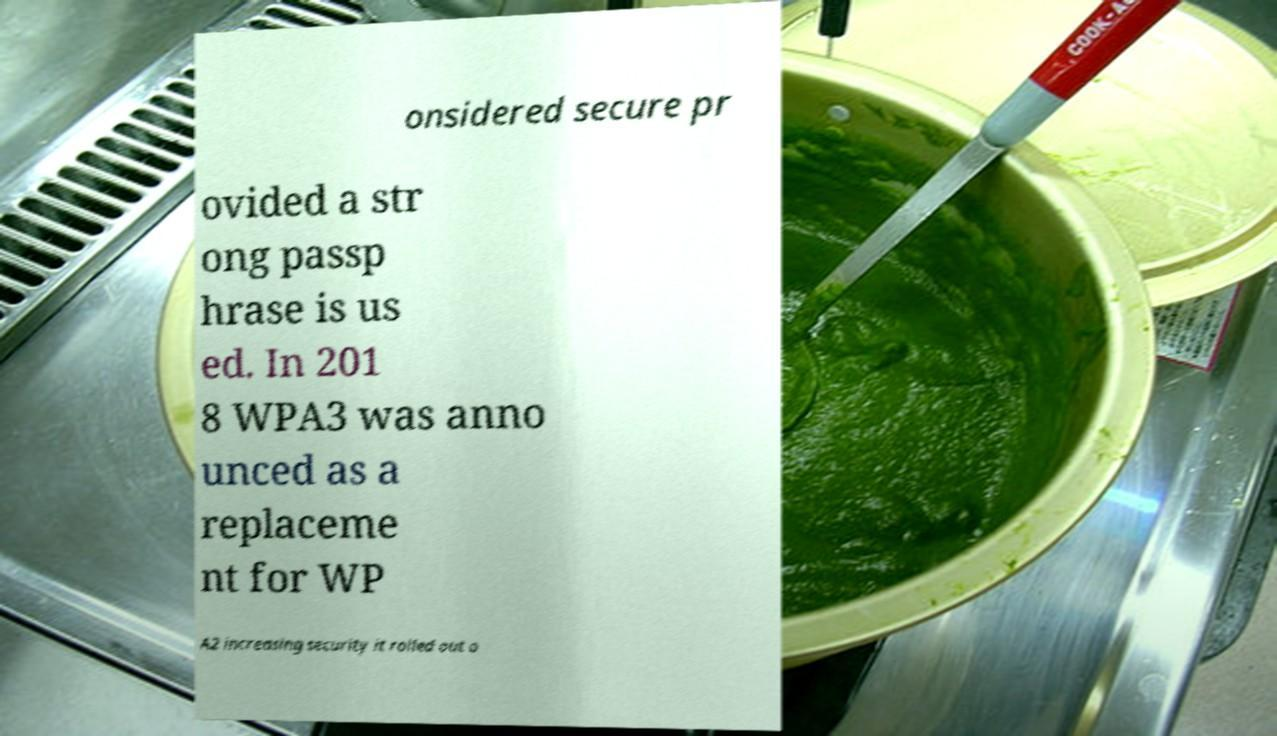Please read and relay the text visible in this image. What does it say? onsidered secure pr ovided a str ong passp hrase is us ed. In 201 8 WPA3 was anno unced as a replaceme nt for WP A2 increasing security it rolled out o 